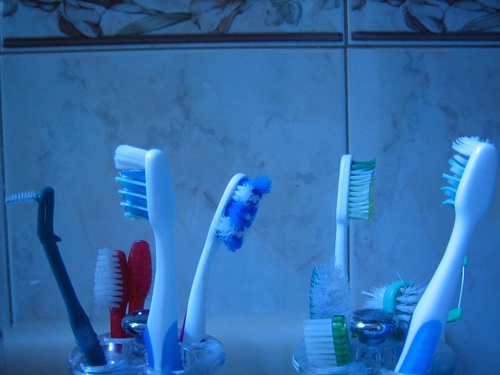Describe the objects in this image and their specific colors. I can see toothbrush in blue, lightblue, and gray tones, toothbrush in blue, lightblue, and gray tones, toothbrush in blue, lightblue, and gray tones, toothbrush in blue, navy, and darkblue tones, and toothbrush in blue, lightblue, gray, and teal tones in this image. 